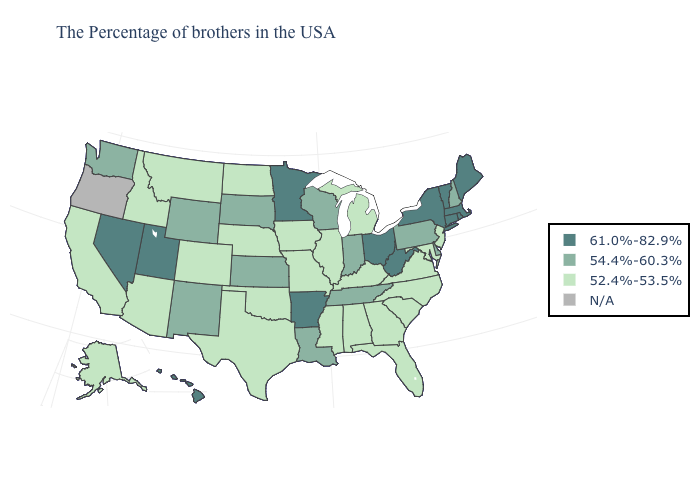Name the states that have a value in the range 52.4%-53.5%?
Short answer required. New Jersey, Maryland, Virginia, North Carolina, South Carolina, Florida, Georgia, Michigan, Kentucky, Alabama, Illinois, Mississippi, Missouri, Iowa, Nebraska, Oklahoma, Texas, North Dakota, Colorado, Montana, Arizona, Idaho, California, Alaska. Name the states that have a value in the range 52.4%-53.5%?
Keep it brief. New Jersey, Maryland, Virginia, North Carolina, South Carolina, Florida, Georgia, Michigan, Kentucky, Alabama, Illinois, Mississippi, Missouri, Iowa, Nebraska, Oklahoma, Texas, North Dakota, Colorado, Montana, Arizona, Idaho, California, Alaska. Does Pennsylvania have the highest value in the Northeast?
Answer briefly. No. Which states hav the highest value in the Northeast?
Answer briefly. Maine, Massachusetts, Rhode Island, Vermont, Connecticut, New York. What is the lowest value in states that border Montana?
Be succinct. 52.4%-53.5%. Does Arizona have the highest value in the USA?
Short answer required. No. Is the legend a continuous bar?
Concise answer only. No. What is the value of Oregon?
Short answer required. N/A. Name the states that have a value in the range N/A?
Give a very brief answer. Oregon. Does New Hampshire have the highest value in the Northeast?
Short answer required. No. What is the value of Vermont?
Keep it brief. 61.0%-82.9%. What is the value of South Carolina?
Short answer required. 52.4%-53.5%. Among the states that border West Virginia , does Kentucky have the lowest value?
Write a very short answer. Yes. Does West Virginia have the highest value in the South?
Give a very brief answer. Yes. 